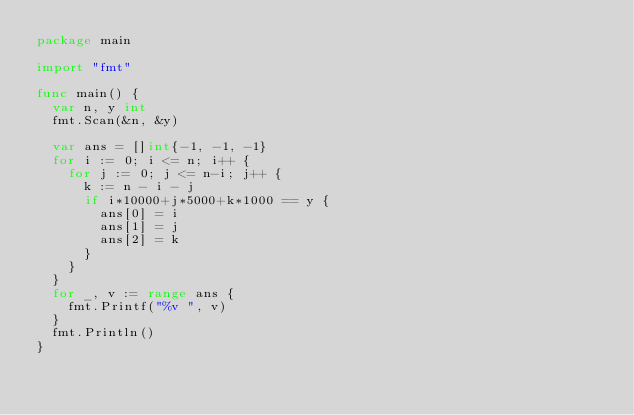<code> <loc_0><loc_0><loc_500><loc_500><_Go_>package main

import "fmt"

func main() {
	var n, y int
	fmt.Scan(&n, &y)

	var ans = []int{-1, -1, -1}
	for i := 0; i <= n; i++ {
		for j := 0; j <= n-i; j++ {
			k := n - i - j
			if i*10000+j*5000+k*1000 == y {
				ans[0] = i
				ans[1] = j
				ans[2] = k
			}
		}
	}
	for _, v := range ans {
		fmt.Printf("%v ", v)
	}
	fmt.Println()
}
</code> 